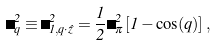<formula> <loc_0><loc_0><loc_500><loc_500>\Omega ^ { 2 } _ { q } \equiv \Omega ^ { 2 } _ { 1 , q \cdot \hat { z } } = \frac { 1 } { 2 } \Omega _ { \pi } ^ { 2 } \left [ 1 - \cos ( q ) \right ] ,</formula> 